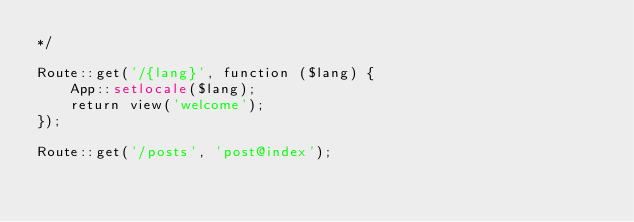<code> <loc_0><loc_0><loc_500><loc_500><_PHP_>*/

Route::get('/{lang}', function ($lang) {
    App::setlocale($lang);
    return view('welcome');
});

Route::get('/posts', 'post@index');
</code> 